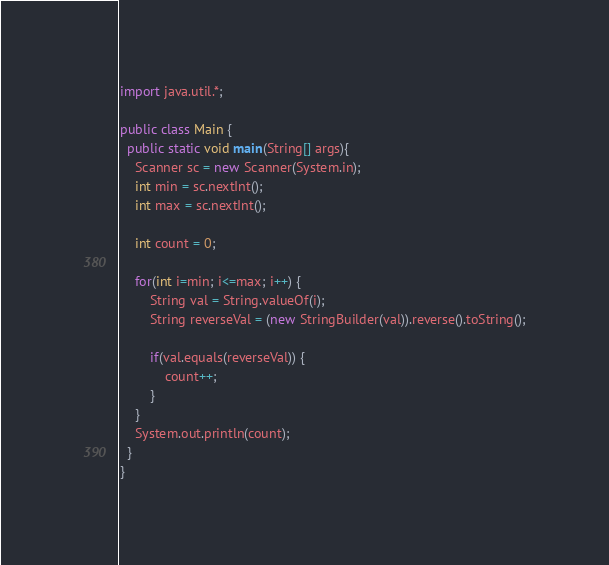Convert code to text. <code><loc_0><loc_0><loc_500><loc_500><_Java_>import java.util.*;

public class Main {
  public static void main(String[] args){
    Scanner sc = new Scanner(System.in);
    int min = sc.nextInt();
    int max = sc.nextInt();
        
    int count = 0;
        
    for(int i=min; i<=max; i++) {
        String val = String.valueOf(i);
        String reverseVal = (new StringBuilder(val)).reverse().toString();

        if(val.equals(reverseVal)) {
        	count++;
    	}
    }
    System.out.println(count);
  }
}</code> 